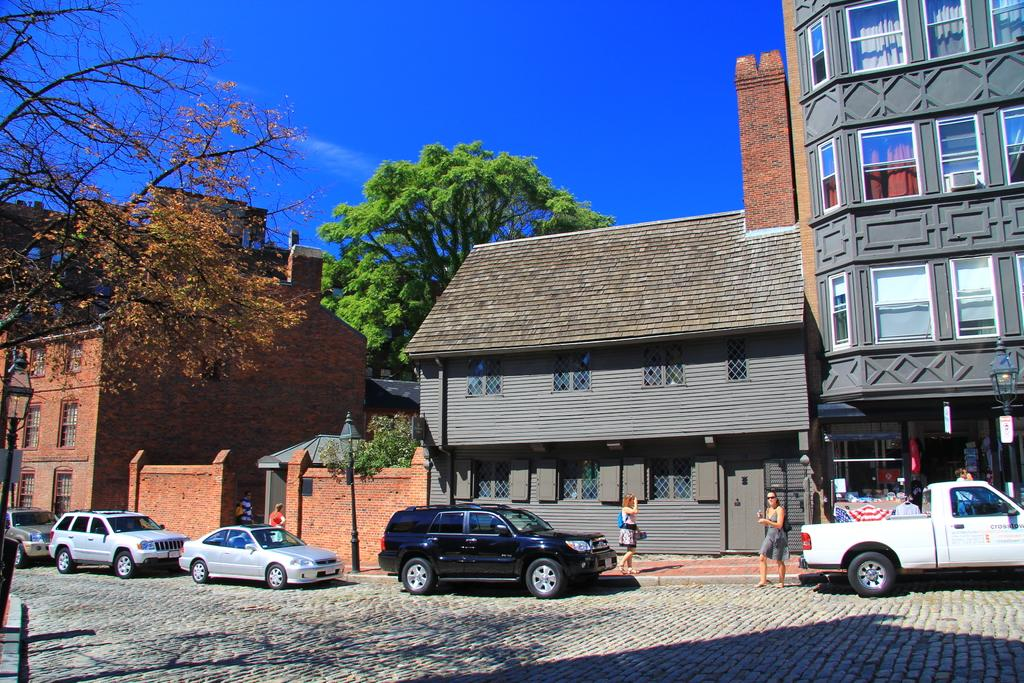What can be seen on the road in the image? There are vehicles on the road in the image. Can you identify any living beings in the image? Yes, there are people visible in the image. What type of natural elements are present in the image? There are trees in the image. What type of structures can be seen in the image? There are houses, poles, boards, and a building in the image. What is visible in the background of the image? The sky is visible in the background of the image. How much coal is being transported by the vehicles in the image? There is no mention of coal in the image, so it cannot be determined how much coal is being transported. Are there any sticks visible in the image? No, there are no sticks visible in the image. 